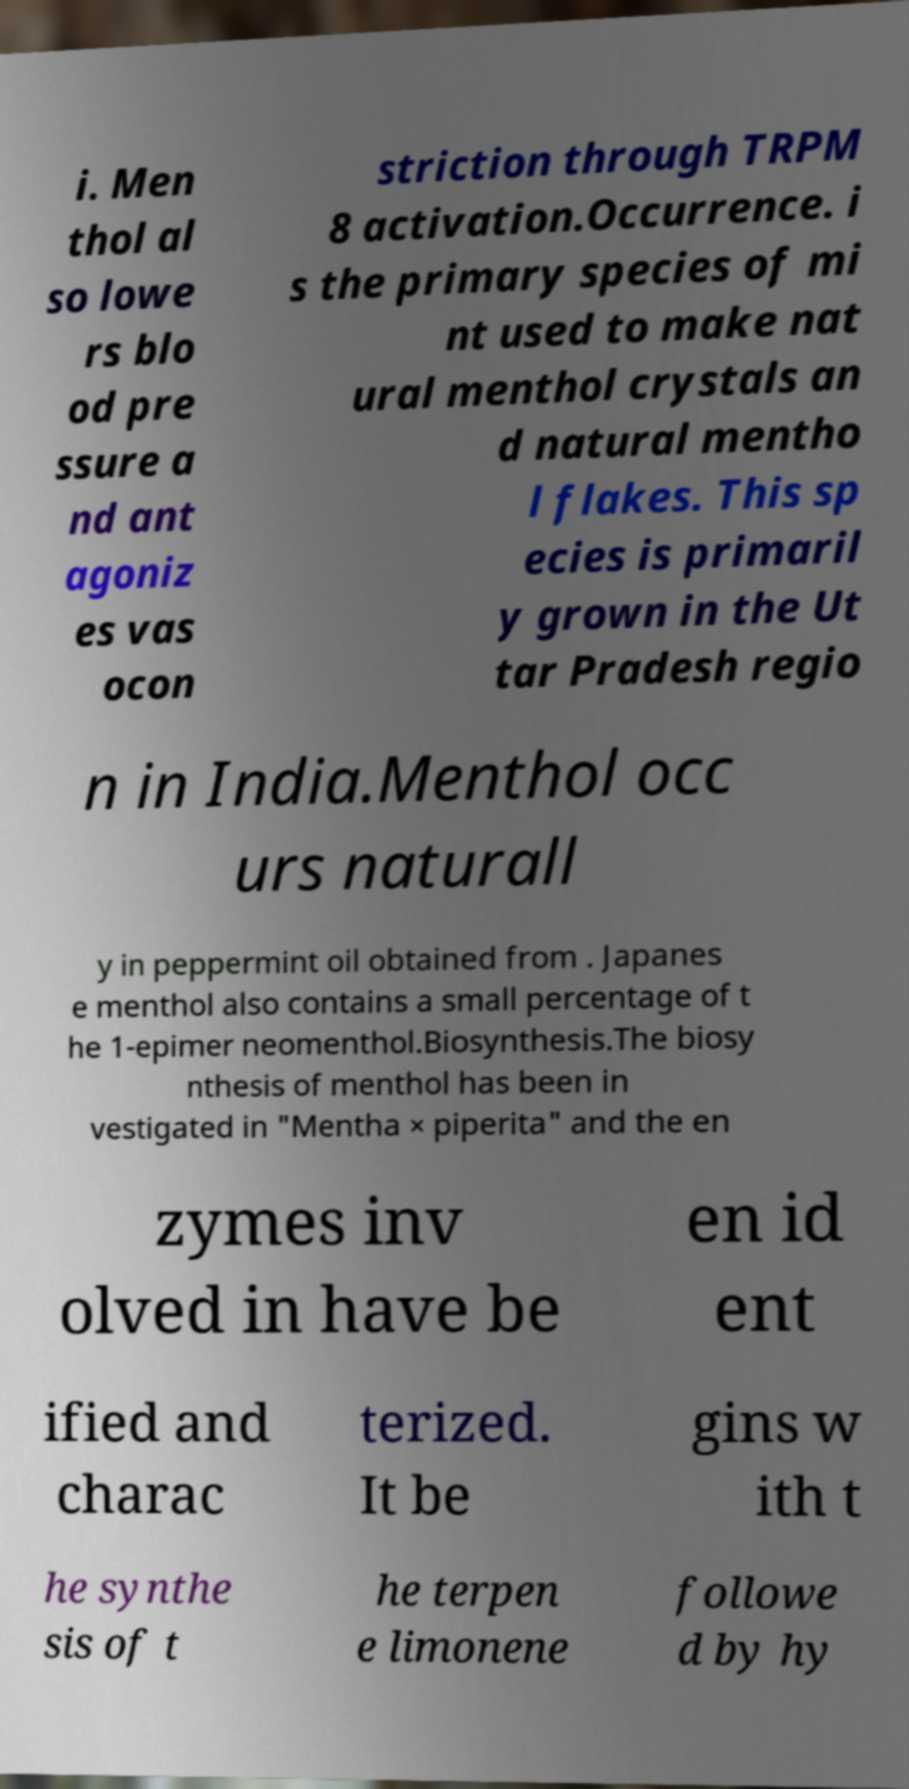Please read and relay the text visible in this image. What does it say? i. Men thol al so lowe rs blo od pre ssure a nd ant agoniz es vas ocon striction through TRPM 8 activation.Occurrence. i s the primary species of mi nt used to make nat ural menthol crystals an d natural mentho l flakes. This sp ecies is primaril y grown in the Ut tar Pradesh regio n in India.Menthol occ urs naturall y in peppermint oil obtained from . Japanes e menthol also contains a small percentage of t he 1-epimer neomenthol.Biosynthesis.The biosy nthesis of menthol has been in vestigated in "Mentha × piperita" and the en zymes inv olved in have be en id ent ified and charac terized. It be gins w ith t he synthe sis of t he terpen e limonene followe d by hy 